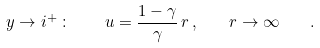Convert formula to latex. <formula><loc_0><loc_0><loc_500><loc_500>y \to i ^ { + } \, \colon \, \quad u = \frac { 1 - \gamma } { \gamma } \, r \, , \quad r \to \infty \quad .</formula> 